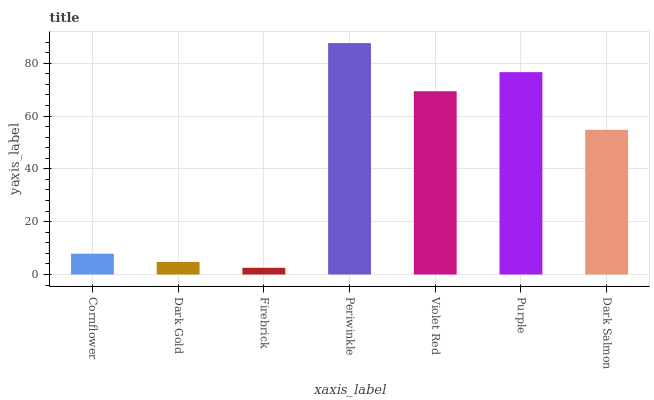Is Firebrick the minimum?
Answer yes or no. Yes. Is Periwinkle the maximum?
Answer yes or no. Yes. Is Dark Gold the minimum?
Answer yes or no. No. Is Dark Gold the maximum?
Answer yes or no. No. Is Cornflower greater than Dark Gold?
Answer yes or no. Yes. Is Dark Gold less than Cornflower?
Answer yes or no. Yes. Is Dark Gold greater than Cornflower?
Answer yes or no. No. Is Cornflower less than Dark Gold?
Answer yes or no. No. Is Dark Salmon the high median?
Answer yes or no. Yes. Is Dark Salmon the low median?
Answer yes or no. Yes. Is Periwinkle the high median?
Answer yes or no. No. Is Cornflower the low median?
Answer yes or no. No. 